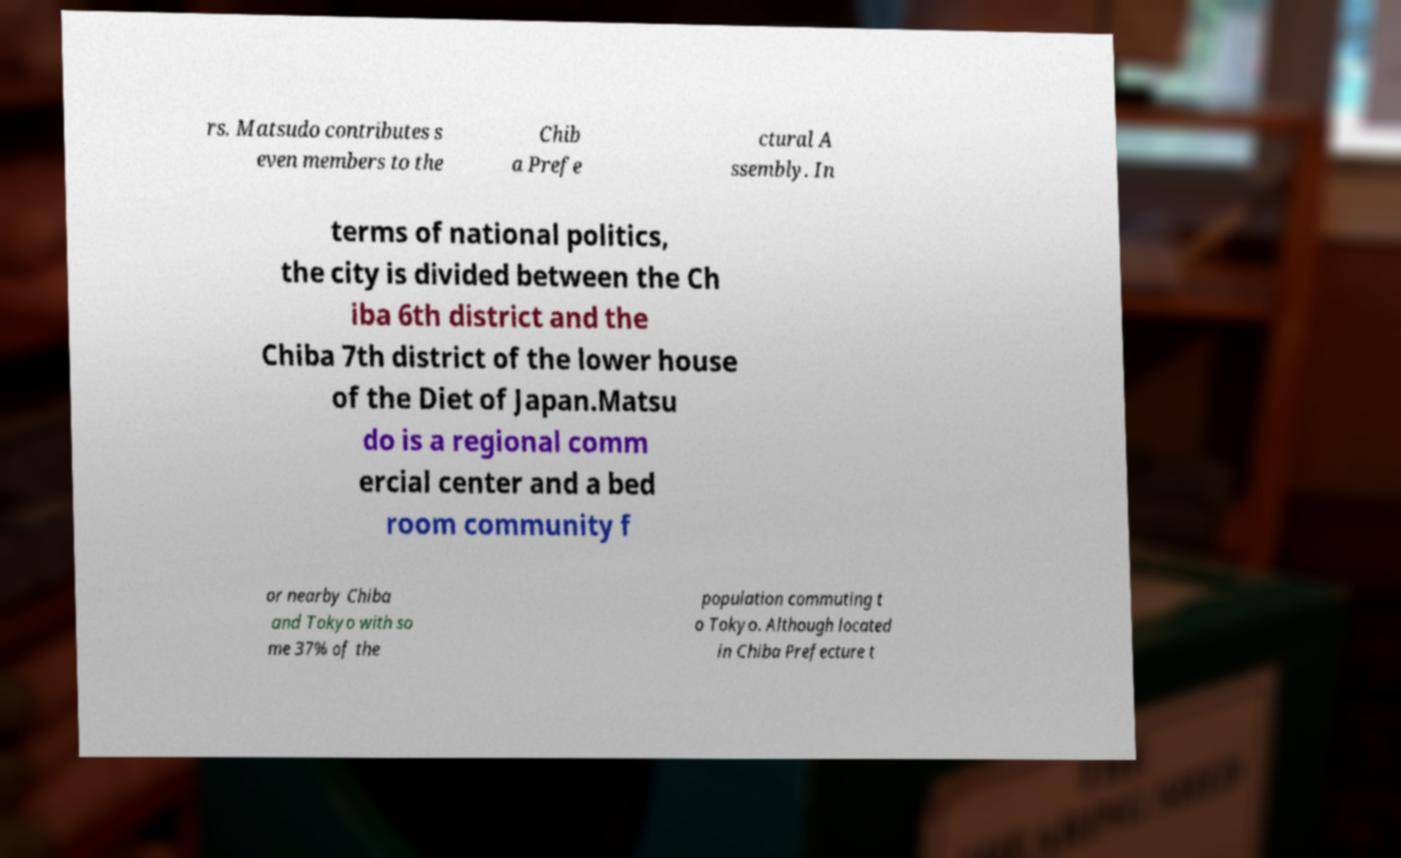Can you read and provide the text displayed in the image?This photo seems to have some interesting text. Can you extract and type it out for me? rs. Matsudo contributes s even members to the Chib a Prefe ctural A ssembly. In terms of national politics, the city is divided between the Ch iba 6th district and the Chiba 7th district of the lower house of the Diet of Japan.Matsu do is a regional comm ercial center and a bed room community f or nearby Chiba and Tokyo with so me 37% of the population commuting t o Tokyo. Although located in Chiba Prefecture t 